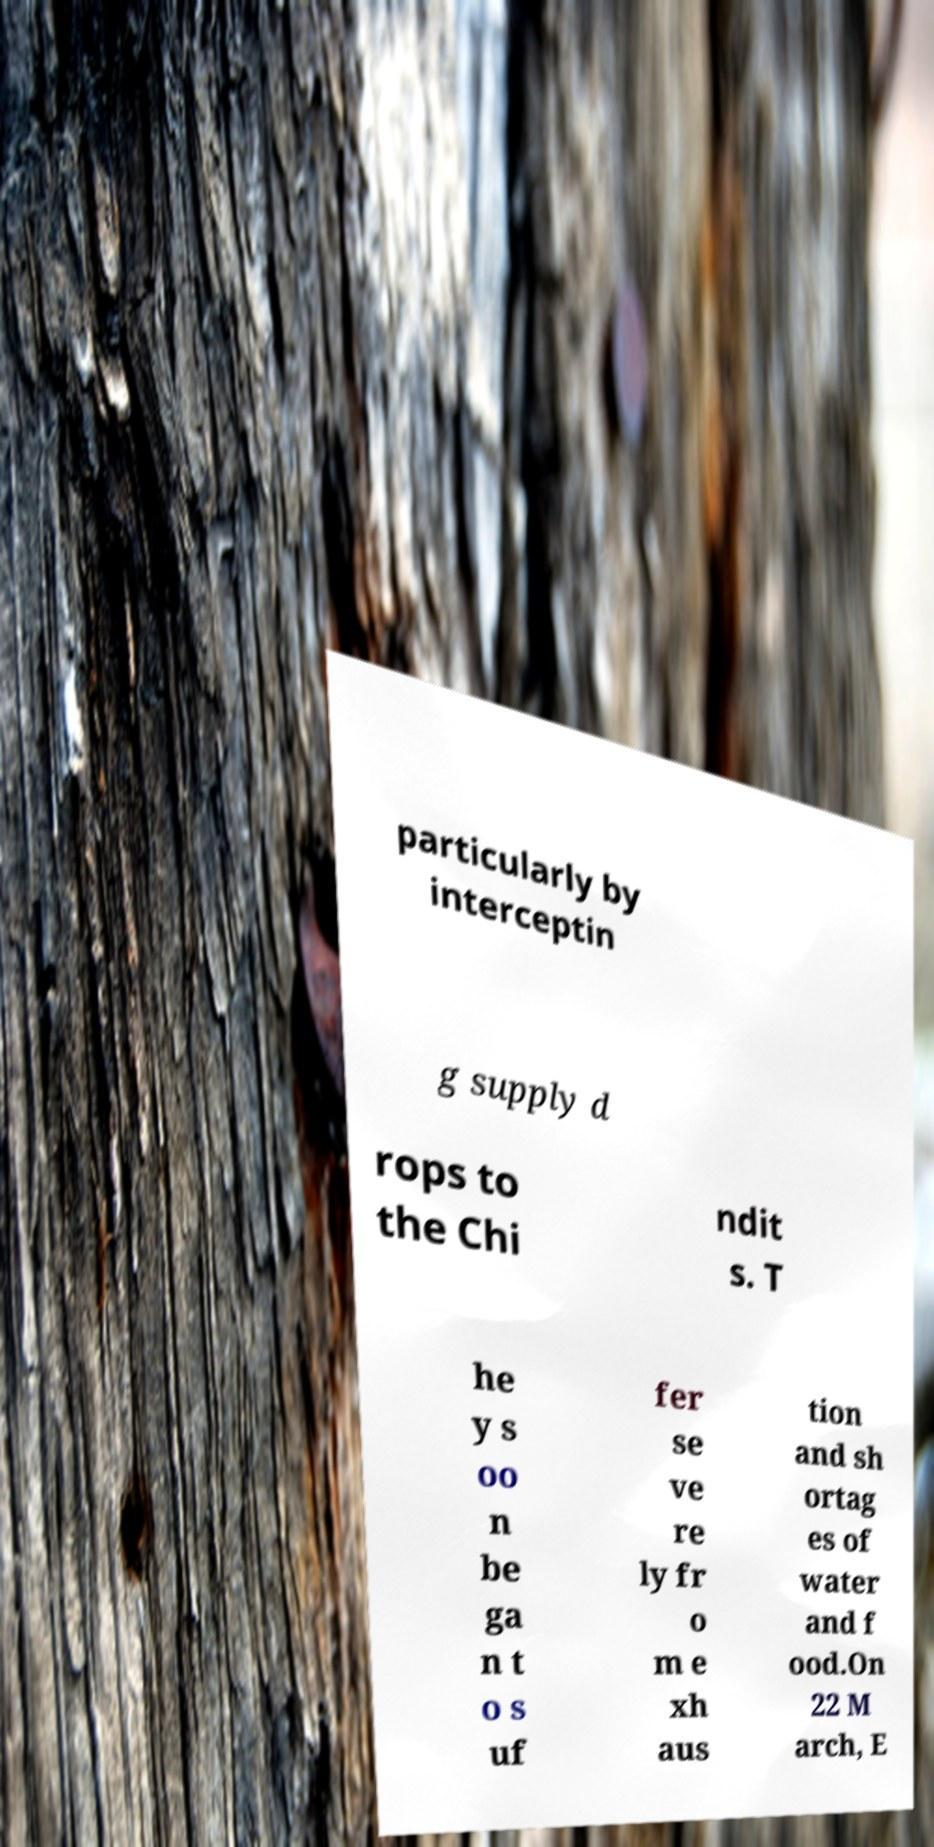Could you extract and type out the text from this image? particularly by interceptin g supply d rops to the Chi ndit s. T he y s oo n be ga n t o s uf fer se ve re ly fr o m e xh aus tion and sh ortag es of water and f ood.On 22 M arch, E 